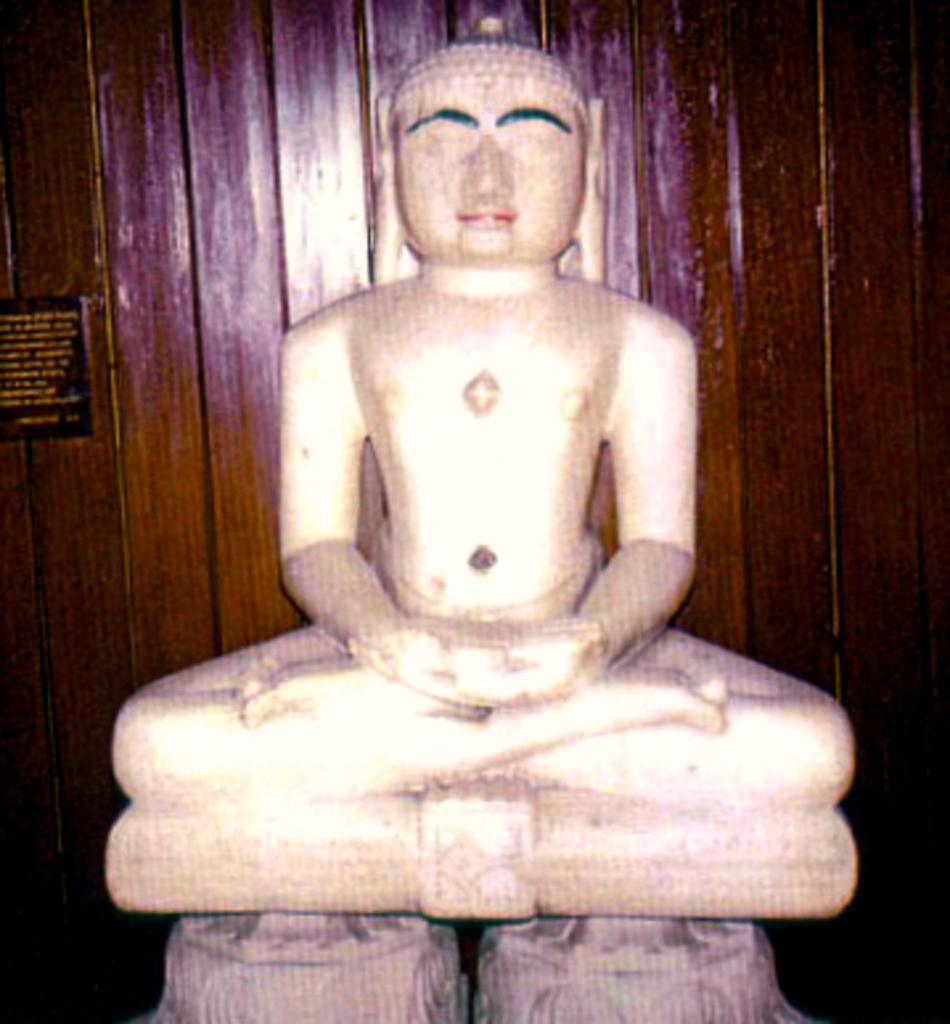What is the main subject of the image? There is a white color statue in the image. What can be observed about the statue's appearance? The statue is white in color. What is the color of the background in the image? The background of the image is in brown color. Can you see the ghost controlling the statue in the image? There is no ghost or any indication of control present in the image. The image features a white color statue with a brown background. 